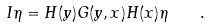<formula> <loc_0><loc_0><loc_500><loc_500>I \eta = H ( y ) G ( y , x ) H ( x ) \eta \quad .</formula> 